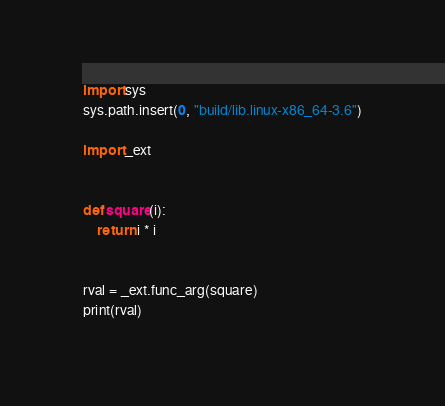<code> <loc_0><loc_0><loc_500><loc_500><_Python_>import sys
sys.path.insert(0, "build/lib.linux-x86_64-3.6")

import _ext


def square(i):
    return i * i


rval = _ext.func_arg(square)
print(rval)
</code> 